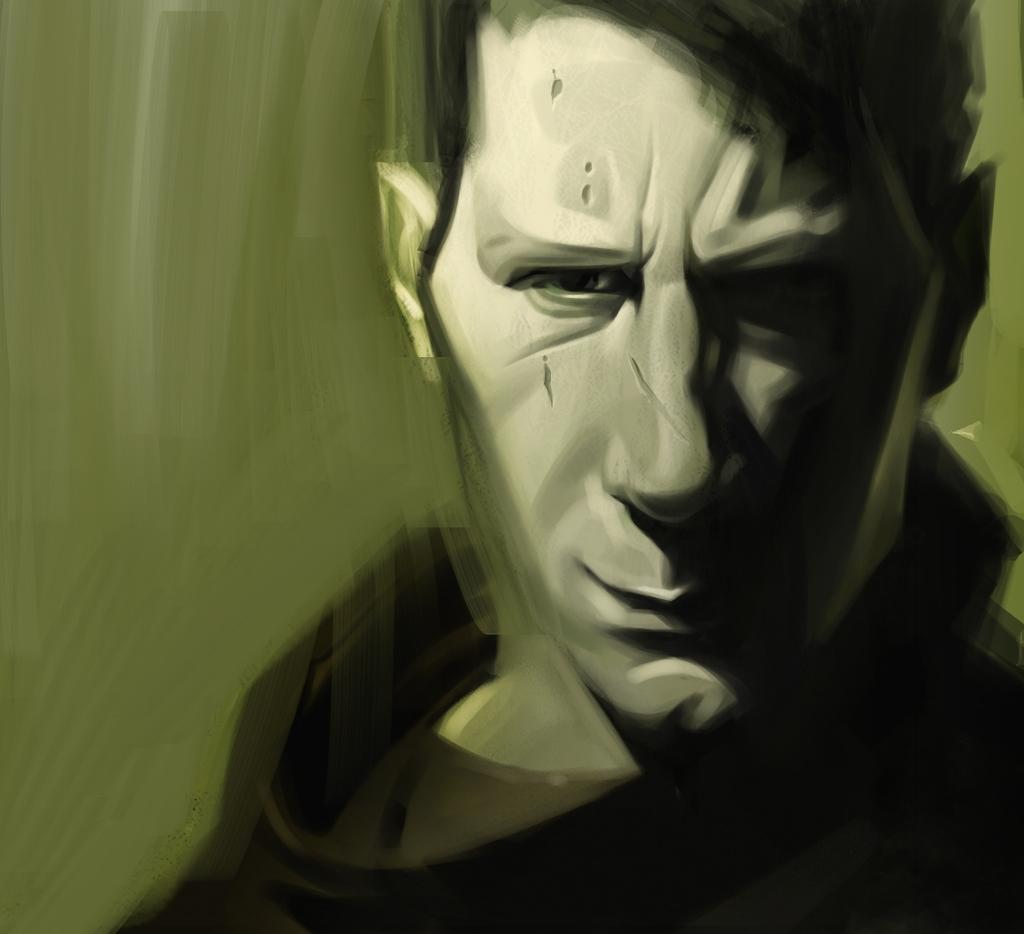What is the main subject of the image? There is a person in the image. Can you describe the background of the image? The background of the image is blurred. How many ants can be seen carrying a point in the image? There are no ants or points present in the image; it features a person with a blurred background. 